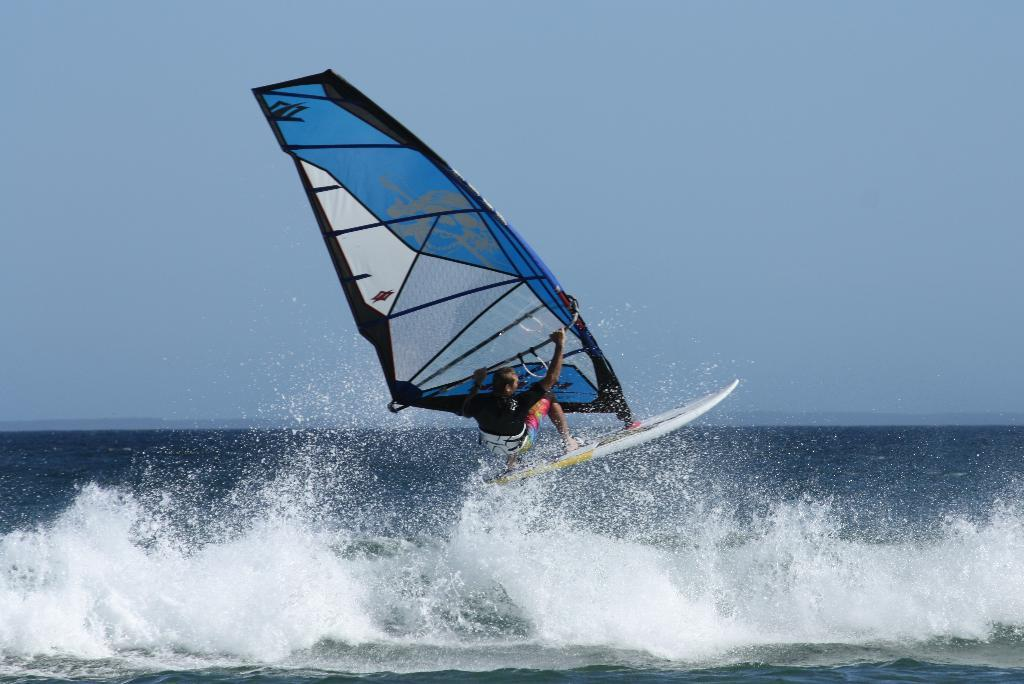What is the person in the image doing? The person is windsurfing. Where is the windsurfing taking place? The windsurfing is taking place in the ocean. What can be seen above the ocean in the image? The sky is visible above the ocean. How many iron attractions can be seen in the image? There are no iron attractions present in the image. What type of dime is floating in the ocean in the image? There is no dime present in the image. 